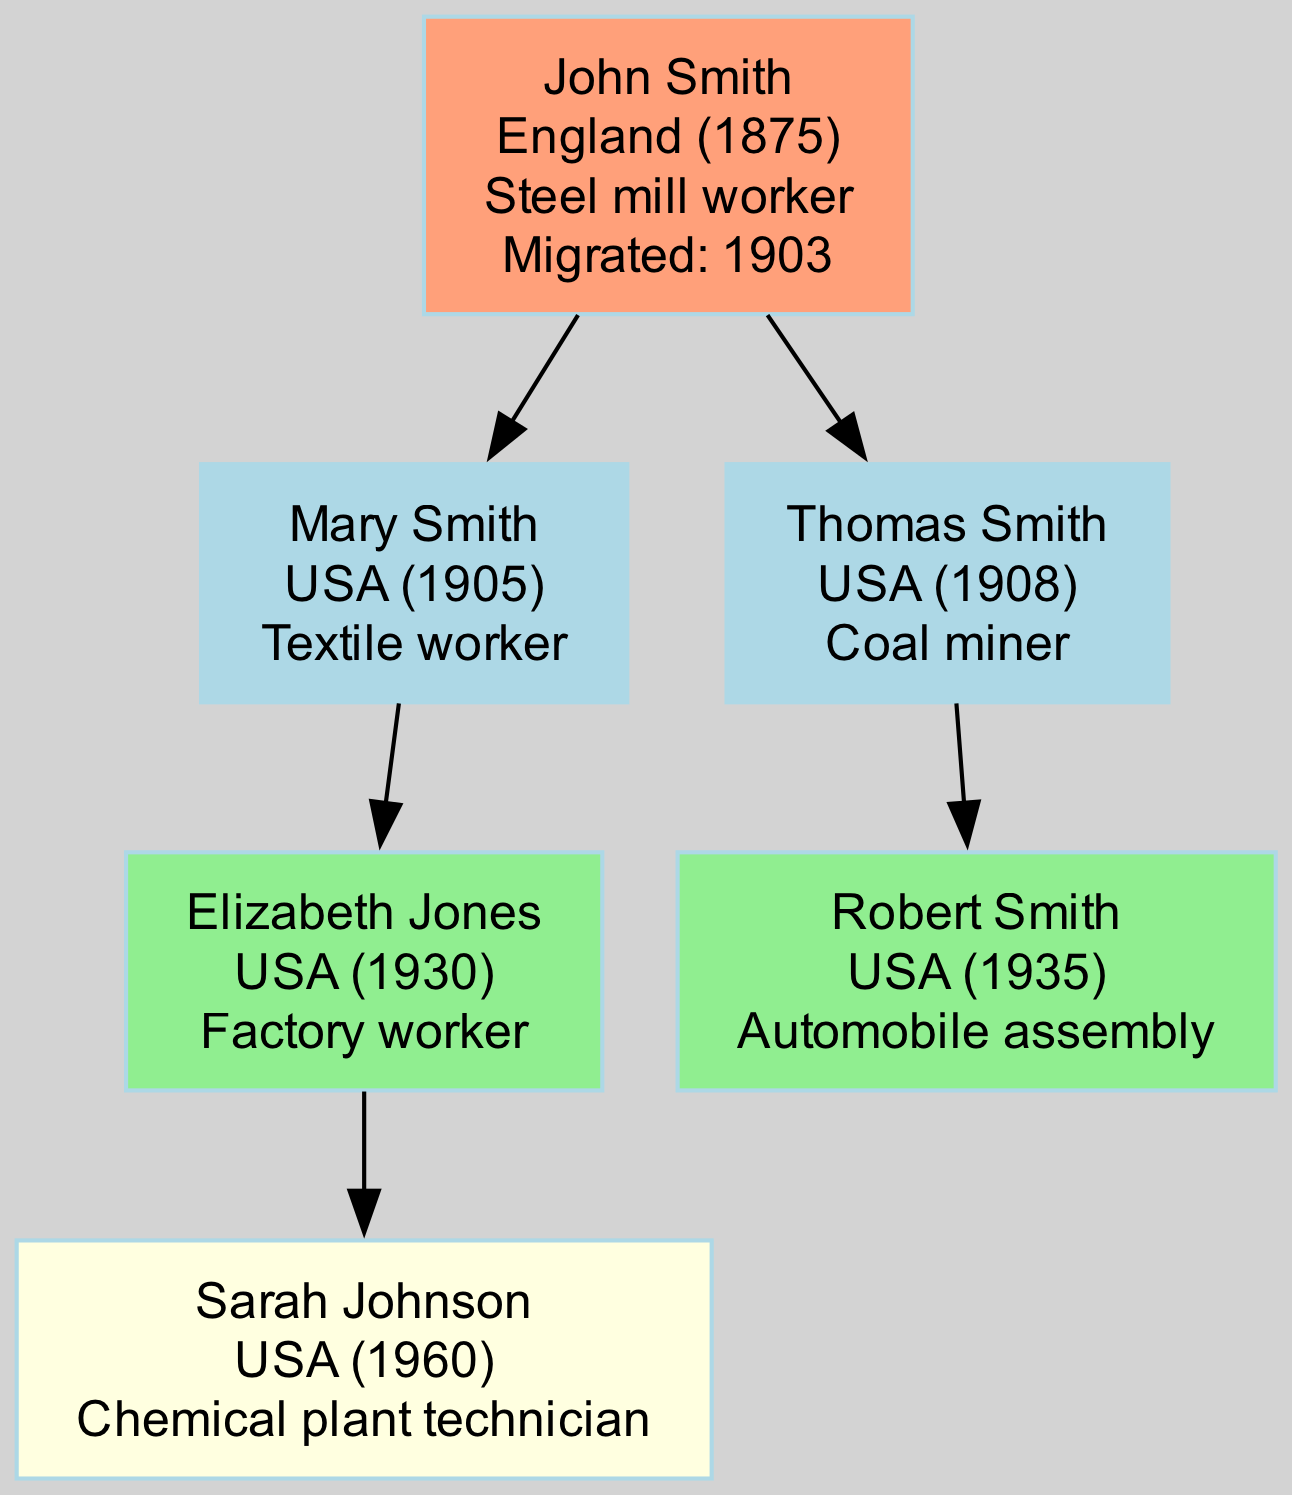What is the birth country of John Smith? John Smith's birth country is specified in the root node of the diagram. The diagram clearly states that he was born in England.
Answer: England How many children does John Smith have? The diagram indicates that John Smith has two children, Mary Smith and Thomas Smith, as shown in the children section.
Answer: 2 What occupation did Mary Smith have? The occupation of Mary Smith is listed in her node under the children section of the diagram. It is specified that she worked as a textile worker.
Answer: Textile worker Who is the granddaughter of John Smith? To find the granddaughter, we can look at the grandchildren node section connected to John's children. Elizabeth Jones and Robert Smith are both grandchildren, but only Elizabeth Jones is the direct granddaughter based on lineage.
Answer: Elizabeth Jones What year did John Smith migrate to the USA? The diagram indicates that John Smith migrated in the year specified in his root node. It states he migrated in 1903.
Answer: 1903 What is the occupation of Robert Smith? The occupation of Robert Smith is available in his node under the grandchildren section. He is identified as working in automobile assembly.
Answer: Automobile assembly Which generation does Sarah Johnson belong to? To determine Sarah Johnson's generation, we can trace her lineage back to John Smith. She is in the great-grandchildren section, which is the fourth generation from John Smith.
Answer: Fourth generation How many grandchildren does John Smith have? The diagram shows that John Smith has two grandchildren, Elizabeth Jones and Robert Smith, listed in the grandchildren section.
Answer: 2 Which grandchild was born first? By examining the birth years provided in the grandchildren section, we can determine that Elizabeth Jones, born in 1930, was born before Robert Smith, who was born in 1935.
Answer: Elizabeth Jones 